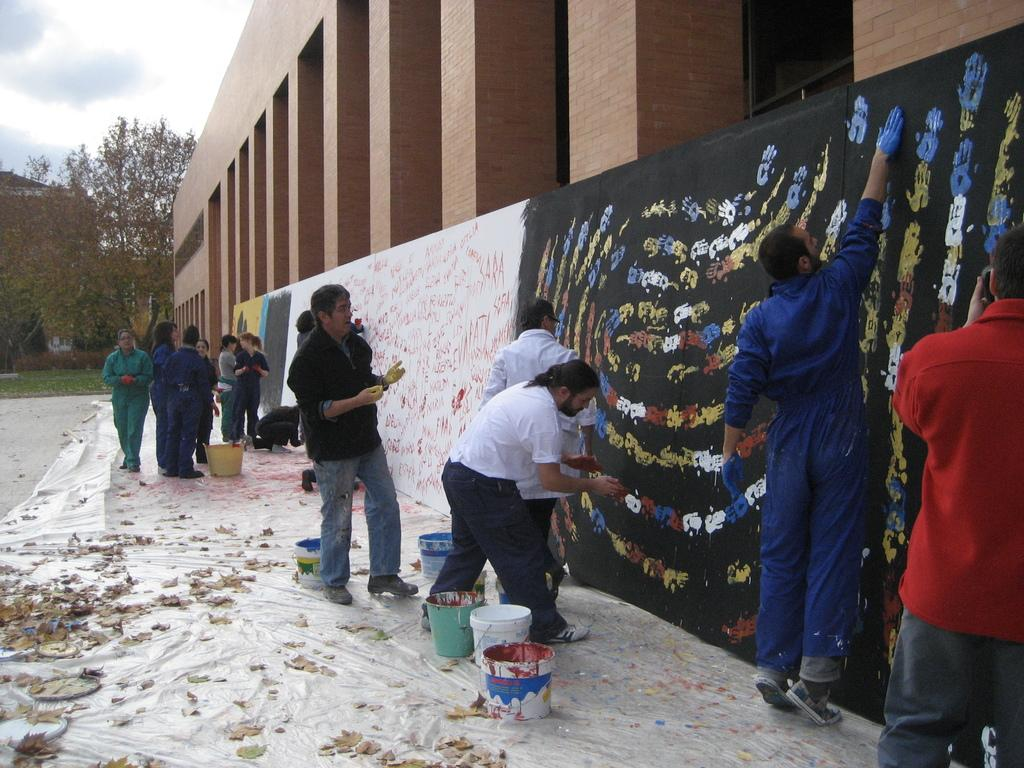What type of structures can be seen in the image? There are buildings in the image. What natural elements are present in the image? There are trees in the image. What objects can be seen near the trees? There are buckets in the image. What additional details can be observed in the image? There are leaves in the image. Are there any living beings in the image? Yes, there are people in the image. What is visible at the top of the image? The sky is visible at the top of the image. What time of day is it in the image, and how does the chin of the person in the image look? The provided facts do not mention the time of day or the appearance of anyone's chin in the image. 